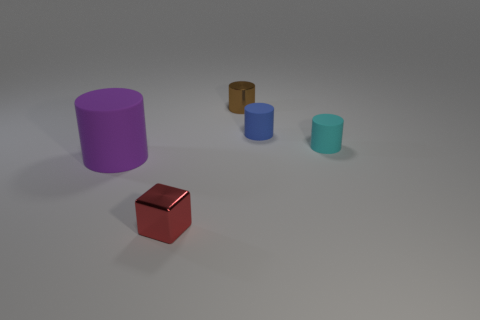There is a cylinder left of the red metal object; what number of small blue rubber things are left of it?
Offer a very short reply. 0. What is the material of the blue cylinder that is the same size as the red cube?
Your answer should be compact. Rubber. How many other things are there of the same material as the tiny blue cylinder?
Offer a terse response. 2. There is a small red metal object; what number of purple cylinders are in front of it?
Your answer should be compact. 0. How many blocks are large purple things or red things?
Provide a short and direct response. 1. There is a thing that is both left of the tiny shiny cylinder and on the right side of the big purple cylinder; what size is it?
Your answer should be very brief. Small. What number of other objects are the same color as the big rubber cylinder?
Your answer should be compact. 0. Is the material of the brown object the same as the small object that is left of the tiny brown thing?
Offer a terse response. Yes. What number of objects are tiny metal things in front of the brown metal cylinder or big purple cubes?
Your answer should be compact. 1. There is a matte object that is on the right side of the purple cylinder and in front of the small blue rubber object; what shape is it?
Offer a terse response. Cylinder. 